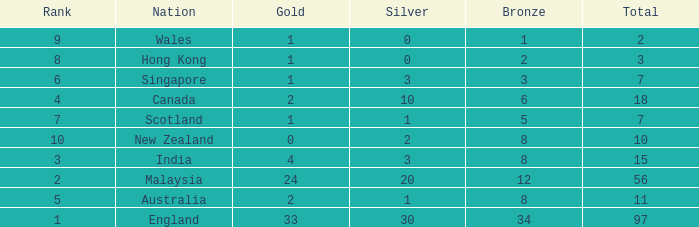What is the most gold medals a team with less than 2 silvers, more than 7 total medals, and less than 8 bronze medals has? None. 